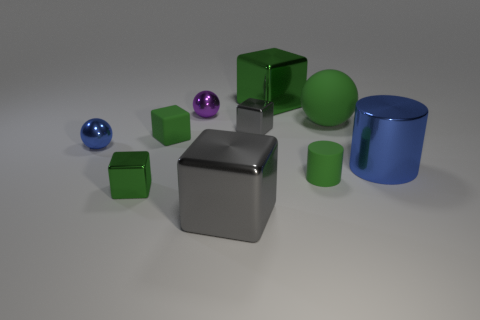Which shapes are present more than once in this image? The image features several shapes in multiples - cubes and cylinders. There are four cubes (three green and one gray) and two cylinders (one green and one blue). 